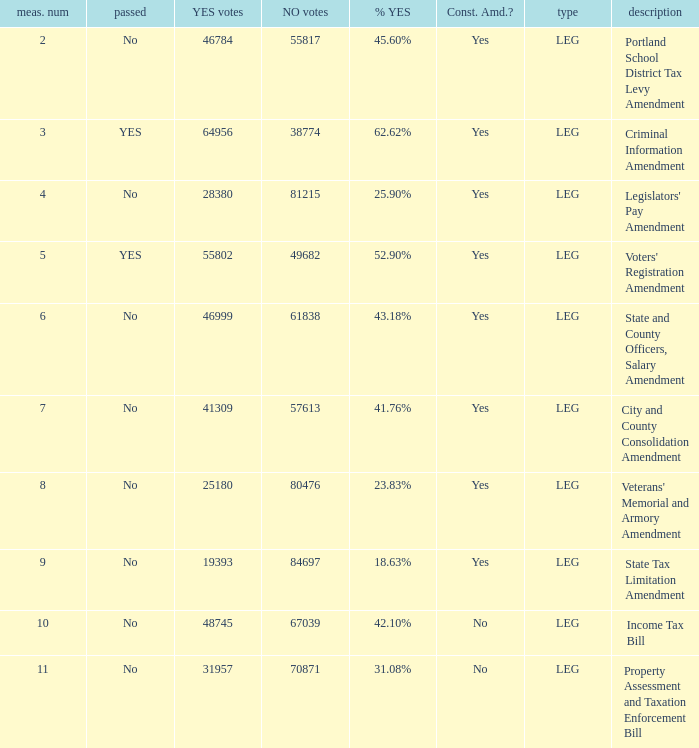18% yes? 46999.0. 